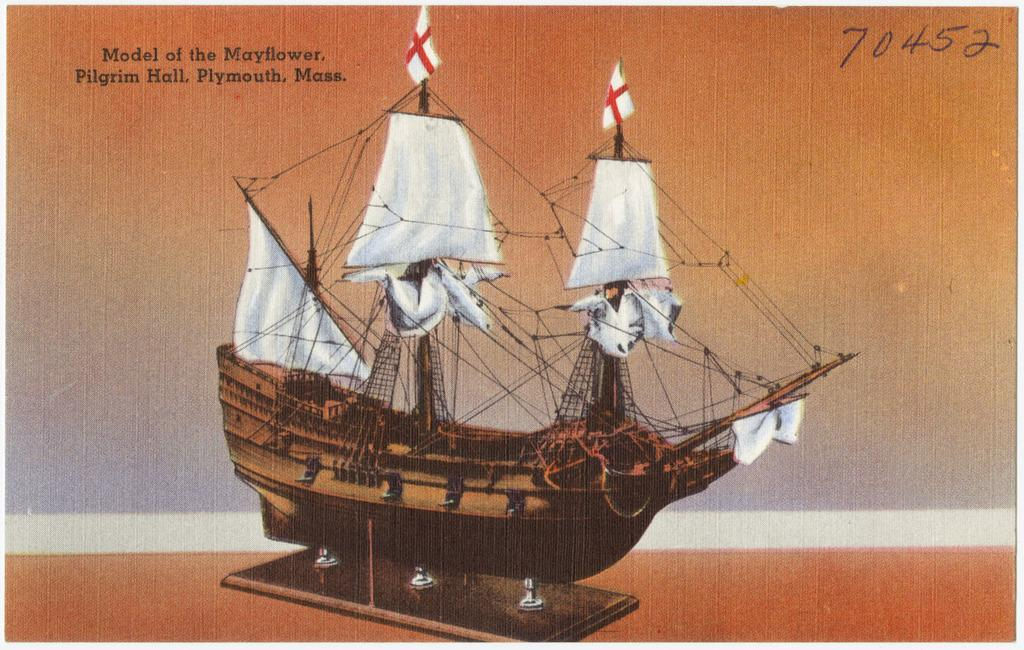What is the main subject of the image? The main subject of the image is a picture of a ship. What features can be seen on the ship? The ship contains poles, ropes, and flags. What can be seen in the background of the image? There is text and numbers visible in the background of the image. How many bears are visible on the ship in the image? There are no bears visible on the ship in the image. Can you purchase a ticket for the ship in the image? There is no information about purchasing a ticket for the ship in the image. What type of hammer is being used to fix the ship in the image? There is no hammer visible in the image. 